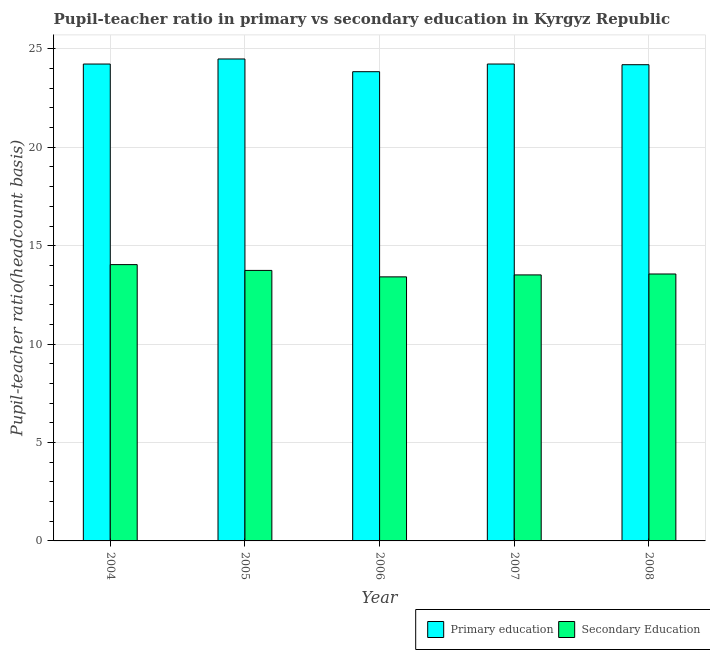How many groups of bars are there?
Provide a succinct answer. 5. What is the label of the 1st group of bars from the left?
Ensure brevity in your answer.  2004. What is the pupil teacher ratio on secondary education in 2008?
Your answer should be very brief. 13.56. Across all years, what is the maximum pupil teacher ratio on secondary education?
Provide a succinct answer. 14.04. Across all years, what is the minimum pupil-teacher ratio in primary education?
Offer a terse response. 23.84. In which year was the pupil teacher ratio on secondary education maximum?
Your response must be concise. 2004. In which year was the pupil teacher ratio on secondary education minimum?
Your answer should be compact. 2006. What is the total pupil-teacher ratio in primary education in the graph?
Ensure brevity in your answer.  120.99. What is the difference between the pupil-teacher ratio in primary education in 2007 and that in 2008?
Provide a short and direct response. 0.03. What is the difference between the pupil-teacher ratio in primary education in 2006 and the pupil teacher ratio on secondary education in 2004?
Keep it short and to the point. -0.39. What is the average pupil teacher ratio on secondary education per year?
Make the answer very short. 13.66. In how many years, is the pupil-teacher ratio in primary education greater than 1?
Provide a short and direct response. 5. What is the ratio of the pupil teacher ratio on secondary education in 2004 to that in 2006?
Keep it short and to the point. 1.05. What is the difference between the highest and the second highest pupil-teacher ratio in primary education?
Your answer should be very brief. 0.26. What is the difference between the highest and the lowest pupil-teacher ratio in primary education?
Provide a short and direct response. 0.65. In how many years, is the pupil-teacher ratio in primary education greater than the average pupil-teacher ratio in primary education taken over all years?
Your answer should be very brief. 3. Is the sum of the pupil-teacher ratio in primary education in 2006 and 2007 greater than the maximum pupil teacher ratio on secondary education across all years?
Your answer should be compact. Yes. What does the 2nd bar from the left in 2005 represents?
Ensure brevity in your answer.  Secondary Education. How many bars are there?
Your response must be concise. 10. Are all the bars in the graph horizontal?
Your response must be concise. No. How many years are there in the graph?
Offer a terse response. 5. Does the graph contain any zero values?
Your answer should be compact. No. Does the graph contain grids?
Offer a terse response. Yes. Where does the legend appear in the graph?
Make the answer very short. Bottom right. How many legend labels are there?
Provide a short and direct response. 2. What is the title of the graph?
Offer a terse response. Pupil-teacher ratio in primary vs secondary education in Kyrgyz Republic. What is the label or title of the X-axis?
Offer a terse response. Year. What is the label or title of the Y-axis?
Give a very brief answer. Pupil-teacher ratio(headcount basis). What is the Pupil-teacher ratio(headcount basis) of Primary education in 2004?
Keep it short and to the point. 24.23. What is the Pupil-teacher ratio(headcount basis) in Secondary Education in 2004?
Provide a succinct answer. 14.04. What is the Pupil-teacher ratio(headcount basis) of Primary education in 2005?
Offer a terse response. 24.49. What is the Pupil-teacher ratio(headcount basis) in Secondary Education in 2005?
Offer a very short reply. 13.75. What is the Pupil-teacher ratio(headcount basis) in Primary education in 2006?
Offer a terse response. 23.84. What is the Pupil-teacher ratio(headcount basis) of Secondary Education in 2006?
Keep it short and to the point. 13.42. What is the Pupil-teacher ratio(headcount basis) in Primary education in 2007?
Ensure brevity in your answer.  24.23. What is the Pupil-teacher ratio(headcount basis) of Secondary Education in 2007?
Provide a succinct answer. 13.52. What is the Pupil-teacher ratio(headcount basis) of Primary education in 2008?
Give a very brief answer. 24.2. What is the Pupil-teacher ratio(headcount basis) of Secondary Education in 2008?
Ensure brevity in your answer.  13.56. Across all years, what is the maximum Pupil-teacher ratio(headcount basis) in Primary education?
Keep it short and to the point. 24.49. Across all years, what is the maximum Pupil-teacher ratio(headcount basis) of Secondary Education?
Ensure brevity in your answer.  14.04. Across all years, what is the minimum Pupil-teacher ratio(headcount basis) in Primary education?
Provide a short and direct response. 23.84. Across all years, what is the minimum Pupil-teacher ratio(headcount basis) of Secondary Education?
Give a very brief answer. 13.42. What is the total Pupil-teacher ratio(headcount basis) in Primary education in the graph?
Provide a succinct answer. 120.99. What is the total Pupil-teacher ratio(headcount basis) in Secondary Education in the graph?
Keep it short and to the point. 68.28. What is the difference between the Pupil-teacher ratio(headcount basis) of Primary education in 2004 and that in 2005?
Provide a short and direct response. -0.26. What is the difference between the Pupil-teacher ratio(headcount basis) of Secondary Education in 2004 and that in 2005?
Make the answer very short. 0.29. What is the difference between the Pupil-teacher ratio(headcount basis) in Primary education in 2004 and that in 2006?
Your answer should be compact. 0.39. What is the difference between the Pupil-teacher ratio(headcount basis) in Secondary Education in 2004 and that in 2006?
Make the answer very short. 0.62. What is the difference between the Pupil-teacher ratio(headcount basis) in Primary education in 2004 and that in 2007?
Provide a succinct answer. -0. What is the difference between the Pupil-teacher ratio(headcount basis) in Secondary Education in 2004 and that in 2007?
Your answer should be very brief. 0.52. What is the difference between the Pupil-teacher ratio(headcount basis) in Primary education in 2004 and that in 2008?
Your answer should be compact. 0.03. What is the difference between the Pupil-teacher ratio(headcount basis) in Secondary Education in 2004 and that in 2008?
Make the answer very short. 0.48. What is the difference between the Pupil-teacher ratio(headcount basis) of Primary education in 2005 and that in 2006?
Offer a very short reply. 0.65. What is the difference between the Pupil-teacher ratio(headcount basis) of Secondary Education in 2005 and that in 2006?
Make the answer very short. 0.33. What is the difference between the Pupil-teacher ratio(headcount basis) of Primary education in 2005 and that in 2007?
Your answer should be compact. 0.26. What is the difference between the Pupil-teacher ratio(headcount basis) of Secondary Education in 2005 and that in 2007?
Give a very brief answer. 0.23. What is the difference between the Pupil-teacher ratio(headcount basis) of Primary education in 2005 and that in 2008?
Provide a succinct answer. 0.29. What is the difference between the Pupil-teacher ratio(headcount basis) in Secondary Education in 2005 and that in 2008?
Provide a succinct answer. 0.18. What is the difference between the Pupil-teacher ratio(headcount basis) of Primary education in 2006 and that in 2007?
Provide a succinct answer. -0.39. What is the difference between the Pupil-teacher ratio(headcount basis) in Secondary Education in 2006 and that in 2007?
Give a very brief answer. -0.1. What is the difference between the Pupil-teacher ratio(headcount basis) in Primary education in 2006 and that in 2008?
Provide a short and direct response. -0.36. What is the difference between the Pupil-teacher ratio(headcount basis) in Secondary Education in 2006 and that in 2008?
Provide a succinct answer. -0.15. What is the difference between the Pupil-teacher ratio(headcount basis) in Primary education in 2007 and that in 2008?
Your response must be concise. 0.03. What is the difference between the Pupil-teacher ratio(headcount basis) of Secondary Education in 2007 and that in 2008?
Ensure brevity in your answer.  -0.05. What is the difference between the Pupil-teacher ratio(headcount basis) in Primary education in 2004 and the Pupil-teacher ratio(headcount basis) in Secondary Education in 2005?
Your answer should be very brief. 10.49. What is the difference between the Pupil-teacher ratio(headcount basis) in Primary education in 2004 and the Pupil-teacher ratio(headcount basis) in Secondary Education in 2006?
Offer a very short reply. 10.81. What is the difference between the Pupil-teacher ratio(headcount basis) of Primary education in 2004 and the Pupil-teacher ratio(headcount basis) of Secondary Education in 2007?
Give a very brief answer. 10.71. What is the difference between the Pupil-teacher ratio(headcount basis) in Primary education in 2004 and the Pupil-teacher ratio(headcount basis) in Secondary Education in 2008?
Provide a succinct answer. 10.67. What is the difference between the Pupil-teacher ratio(headcount basis) in Primary education in 2005 and the Pupil-teacher ratio(headcount basis) in Secondary Education in 2006?
Make the answer very short. 11.07. What is the difference between the Pupil-teacher ratio(headcount basis) in Primary education in 2005 and the Pupil-teacher ratio(headcount basis) in Secondary Education in 2007?
Keep it short and to the point. 10.97. What is the difference between the Pupil-teacher ratio(headcount basis) of Primary education in 2005 and the Pupil-teacher ratio(headcount basis) of Secondary Education in 2008?
Ensure brevity in your answer.  10.93. What is the difference between the Pupil-teacher ratio(headcount basis) in Primary education in 2006 and the Pupil-teacher ratio(headcount basis) in Secondary Education in 2007?
Your response must be concise. 10.33. What is the difference between the Pupil-teacher ratio(headcount basis) in Primary education in 2006 and the Pupil-teacher ratio(headcount basis) in Secondary Education in 2008?
Your answer should be compact. 10.28. What is the difference between the Pupil-teacher ratio(headcount basis) of Primary education in 2007 and the Pupil-teacher ratio(headcount basis) of Secondary Education in 2008?
Offer a very short reply. 10.67. What is the average Pupil-teacher ratio(headcount basis) in Primary education per year?
Offer a very short reply. 24.2. What is the average Pupil-teacher ratio(headcount basis) of Secondary Education per year?
Ensure brevity in your answer.  13.66. In the year 2004, what is the difference between the Pupil-teacher ratio(headcount basis) in Primary education and Pupil-teacher ratio(headcount basis) in Secondary Education?
Keep it short and to the point. 10.19. In the year 2005, what is the difference between the Pupil-teacher ratio(headcount basis) of Primary education and Pupil-teacher ratio(headcount basis) of Secondary Education?
Your response must be concise. 10.74. In the year 2006, what is the difference between the Pupil-teacher ratio(headcount basis) in Primary education and Pupil-teacher ratio(headcount basis) in Secondary Education?
Ensure brevity in your answer.  10.43. In the year 2007, what is the difference between the Pupil-teacher ratio(headcount basis) of Primary education and Pupil-teacher ratio(headcount basis) of Secondary Education?
Provide a short and direct response. 10.72. In the year 2008, what is the difference between the Pupil-teacher ratio(headcount basis) of Primary education and Pupil-teacher ratio(headcount basis) of Secondary Education?
Give a very brief answer. 10.63. What is the ratio of the Pupil-teacher ratio(headcount basis) in Secondary Education in 2004 to that in 2005?
Your answer should be compact. 1.02. What is the ratio of the Pupil-teacher ratio(headcount basis) in Primary education in 2004 to that in 2006?
Your answer should be very brief. 1.02. What is the ratio of the Pupil-teacher ratio(headcount basis) in Secondary Education in 2004 to that in 2006?
Your response must be concise. 1.05. What is the ratio of the Pupil-teacher ratio(headcount basis) in Secondary Education in 2004 to that in 2007?
Offer a terse response. 1.04. What is the ratio of the Pupil-teacher ratio(headcount basis) of Secondary Education in 2004 to that in 2008?
Offer a terse response. 1.04. What is the ratio of the Pupil-teacher ratio(headcount basis) in Primary education in 2005 to that in 2006?
Give a very brief answer. 1.03. What is the ratio of the Pupil-teacher ratio(headcount basis) of Secondary Education in 2005 to that in 2006?
Keep it short and to the point. 1.02. What is the ratio of the Pupil-teacher ratio(headcount basis) in Primary education in 2005 to that in 2007?
Your response must be concise. 1.01. What is the ratio of the Pupil-teacher ratio(headcount basis) in Secondary Education in 2005 to that in 2007?
Give a very brief answer. 1.02. What is the ratio of the Pupil-teacher ratio(headcount basis) in Secondary Education in 2005 to that in 2008?
Offer a very short reply. 1.01. What is the ratio of the Pupil-teacher ratio(headcount basis) in Primary education in 2006 to that in 2007?
Keep it short and to the point. 0.98. What is the ratio of the Pupil-teacher ratio(headcount basis) in Secondary Education in 2006 to that in 2008?
Provide a short and direct response. 0.99. What is the ratio of the Pupil-teacher ratio(headcount basis) of Primary education in 2007 to that in 2008?
Ensure brevity in your answer.  1. What is the ratio of the Pupil-teacher ratio(headcount basis) of Secondary Education in 2007 to that in 2008?
Make the answer very short. 1. What is the difference between the highest and the second highest Pupil-teacher ratio(headcount basis) of Primary education?
Provide a short and direct response. 0.26. What is the difference between the highest and the second highest Pupil-teacher ratio(headcount basis) of Secondary Education?
Your answer should be very brief. 0.29. What is the difference between the highest and the lowest Pupil-teacher ratio(headcount basis) in Primary education?
Your response must be concise. 0.65. What is the difference between the highest and the lowest Pupil-teacher ratio(headcount basis) of Secondary Education?
Your response must be concise. 0.62. 